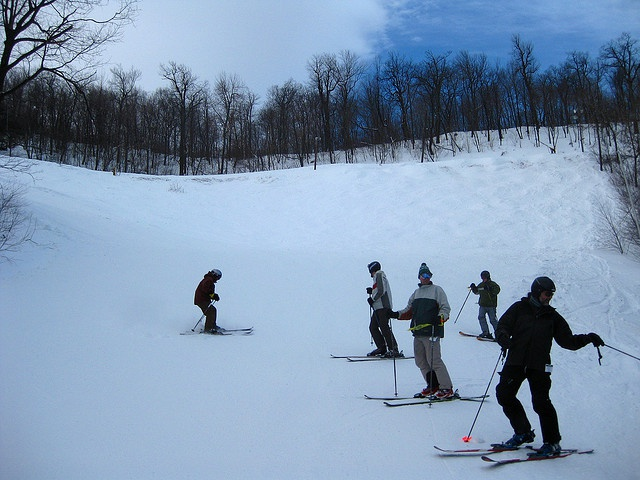Describe the objects in this image and their specific colors. I can see people in gray, black, darkgray, and navy tones, people in gray and black tones, people in gray, black, and lightblue tones, people in gray, black, navy, and lightblue tones, and people in gray, black, and navy tones in this image. 